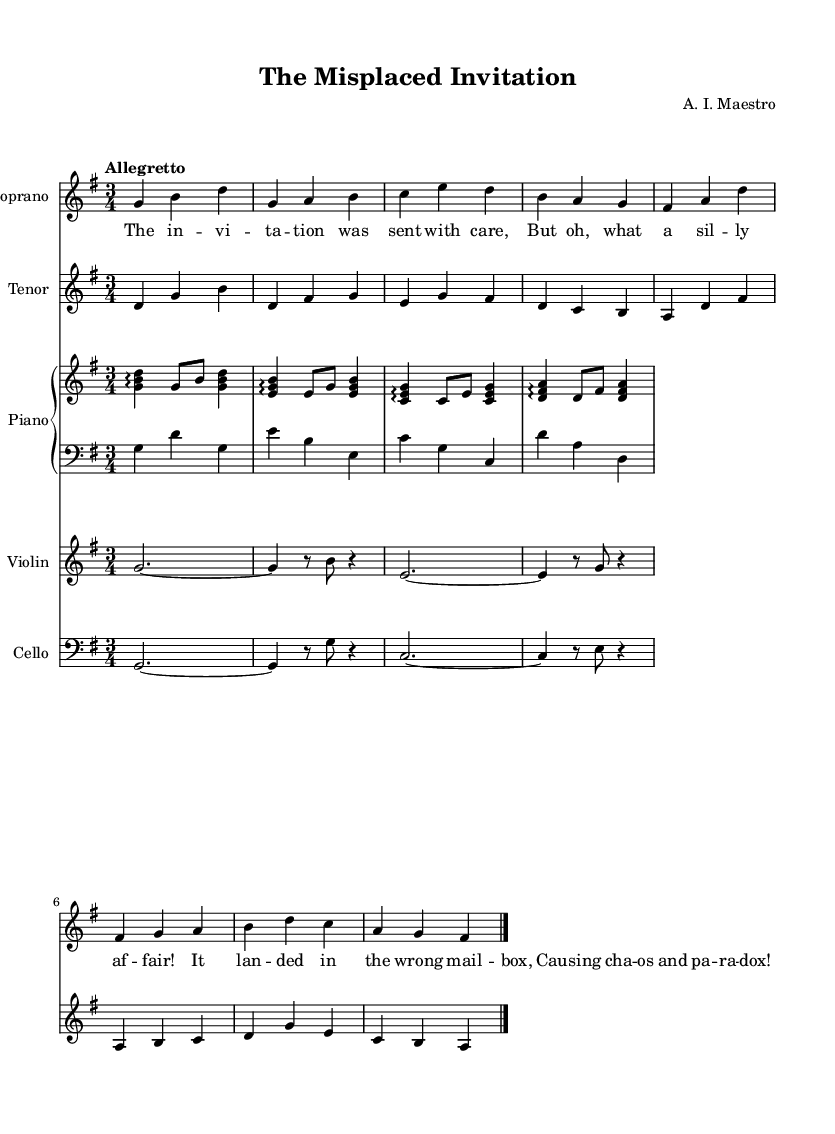What is the key signature of this music? The key signature is indicated at the beginning of the music sheet, which shows one sharp, identifying it as G major.
Answer: G major What is the time signature of this piece? The time signature is indicated at the beginning of the music, showing that the piece is in 3/4 time, meaning there are three beats in a measure.
Answer: 3/4 What is the tempo marking for the piece? The tempo marking indicates the speed at which the piece should be played and is written as "Allegretto," which suggests a moderately fast pace.
Answer: Allegretto How many instruments are included in this score? By counting the different staves, we can identify a total of five different instruments: Soprano, Tenor, Piano (with Right Hand and Left Hand), Violin, and Cello.
Answer: Five What is the title of this opera? The title of the opera is provided in the header of the sheet music and is clearly stated as "The Misplaced Invitation."
Answer: The Misplaced Invitation Which musical section includes lyrics? The lyrics are presented directly below the Soprano staff, showing that the vocal part has accompanying text.
Answer: Soprano What theme is portrayed in this opera? The themes portrayed in the song text revolve around miscommunication, highlighted by phrases in the lyrics that express confusion and silliness stemming from an incorrectly delivered invitation.
Answer: Miscommunication 